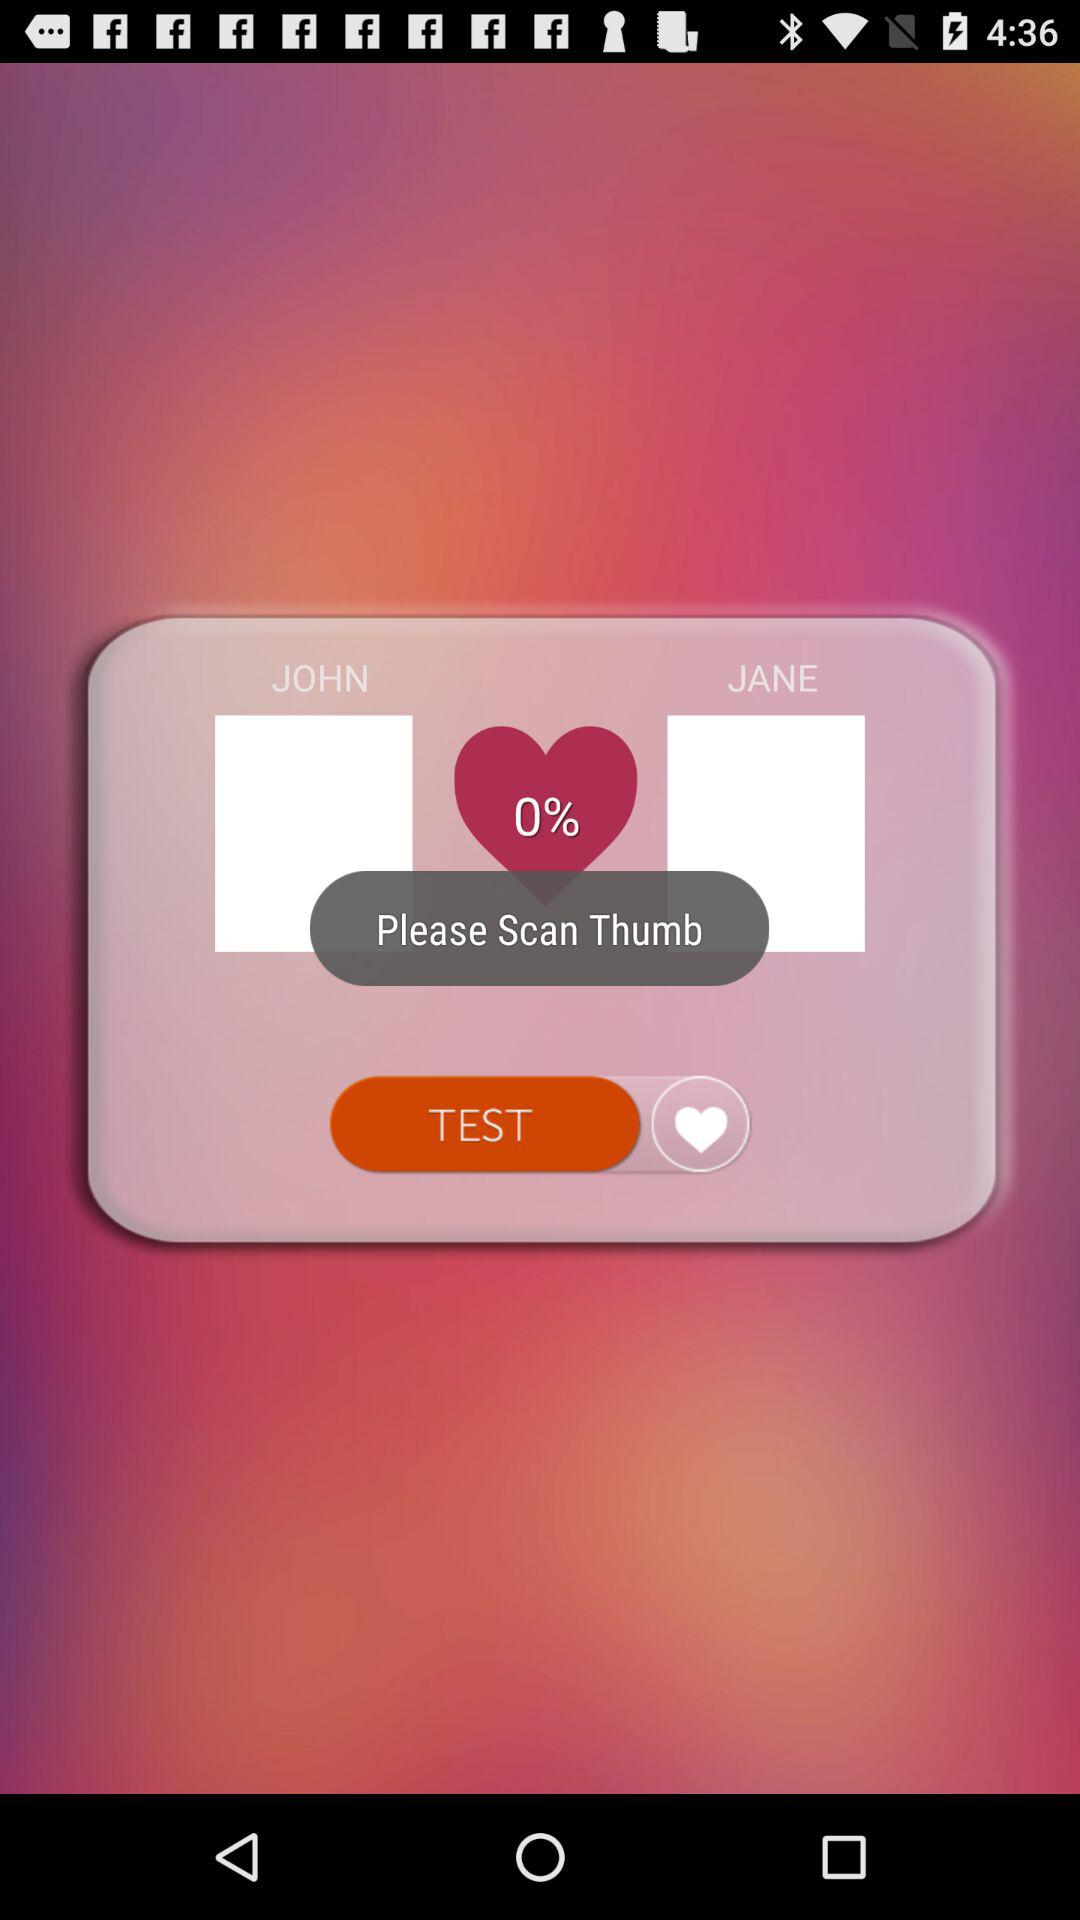How long does the scan take?
When the provided information is insufficient, respond with <no answer>. <no answer> 